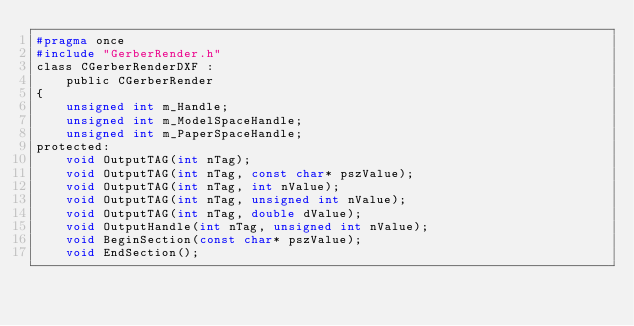<code> <loc_0><loc_0><loc_500><loc_500><_C_>#pragma once
#include "GerberRender.h"
class CGerberRenderDXF :
	public CGerberRender
{
	unsigned int m_Handle;
	unsigned int m_ModelSpaceHandle;
	unsigned int m_PaperSpaceHandle;
protected:
	void OutputTAG(int nTag);
	void OutputTAG(int nTag, const char* pszValue);
	void OutputTAG(int nTag, int nValue);
	void OutputTAG(int nTag, unsigned int nValue);
	void OutputTAG(int nTag, double dValue);
	void OutputHandle(int nTag, unsigned int nValue);
	void BeginSection(const char* pszValue);
	void EndSection();</code> 